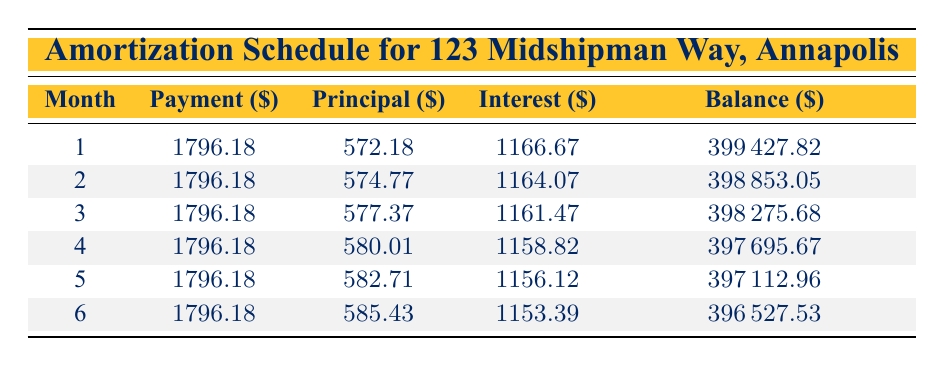What is the monthly payment for the mortgage? The monthly payment can be found in the table under the "Payment" column for each month. It is consistent across all months.
Answer: 1796.18 How much principal is paid off in the first month? In the table, the entry for the first month under the "Principal" column shows the amount of principal paid off.
Answer: 572.18 What is the total interest paid in the first three months? To find the total interest, sum the values in the "Interest" column for the first three months: 1166.67 + 1164.07 + 1161.47 = 3492.21.
Answer: 3492.21 Is the payment amount the same every month? The table shows the same value for the "Payment" column across all months, indicating that the payment amount does not change.
Answer: Yes How much is the remaining balance after six months? The remaining balance after six months is listed in the last row of the table, specifically in the "Balance" column.
Answer: 396527.53 What is the average principal paid off over the first six months? To find the average principal paid, first sum the principal amounts for the first six months: 572.18 + 574.77 + 577.37 + 580.01 + 582.71 + 585.43 = 3472.47. Then divide by 6 to find the average: 3472.47 / 6 = 578.74.
Answer: 578.74 How does the principal payment in the second month compare to the first? The principal payment in the second month (574.77) is compared to the principal payment in the first month (572.18). Since 574.77 - 572.18 = 2.59, it indicates that the principal payment increased by this amount in the second month.
Answer: Increased by 2.59 What is the total amount paid towards interest in the first half-year? To find this, sum the interest payments for the first six months: 1166.67 + 1164.07 + 1161.47 + 1158.82 + 1156.12 + 1153.39 = 6930.54.
Answer: 6930.54 What is the difference in the remaining balance between month 1 and month 6? The remaining balance for the first month is 399427.82, and for the sixth month, it is 396527.53. The difference is calculated as 399427.82 - 396527.53 = 2900.29.
Answer: 2900.29 